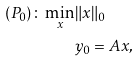<formula> <loc_0><loc_0><loc_500><loc_500>( P _ { 0 } ) \colon \min _ { x } & \| x \| _ { 0 } \\ & y _ { 0 } = A x ,</formula> 